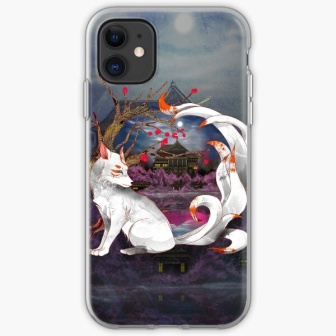Create a whimsical narrative involving all elements of this image. Once upon a time, in the heart of an enchanted realm, there lived a wise and mystical white fox named Luminara. Luminara resided in the ancient castle perched atop a mystical hill that shimmered in the moonlight. Every full moon, the castle would glow with an ethereal light, becoming a beacon of magic and mystery.

One moonlit night, Luminara received a golden ribbon from the Moon Goddess, which when worn, granted the ability to traverse between the realms of reality and dreams. Wrapped in this divine ribbon, Luminara set out on a journey across the night-cloaked landscape, her tail trailing like a comet across the sky.

Travelling through fields of vibrant red flowers and passing ancient, gnarled trees, Luminara encountered various fantastical creatures - from talking owls to dancing fireflies. Each interaction brought new wisdom and reflections on the balance of nature and magic.

Luminara’s quest was to uncover the secrets hidden by the luminescent moon and to bring harmony between the mythical and mortal worlds. With every step, her journey weaved a tapestry of dreams, illuminating the cosmic dance between the stars and the earth below. And thus, the legend of Luminara, the guardian fox of dreams, became an everlasting tale in the hearts of all enchanted by the night.  What historical or cultural elements could be influencing the design in this image? The design appears to draw inspiration from various cultural and historical elements. The fox, a prominent figure in many folklore traditions, especially in East Asian cultures, often symbolizes wisdom, protection, and mystical powers. The ribbon might reference ancient myths where such accessories possess magical properties or signify noble status.

The castle evokes imagery of medieval or feudal architecture, suggesting a setting rich in history and intrigue. The full moon and its influence are pervasive in cultures worldwide, often associated with transformation, purity, and emotional depth. The vivid red flowers could symbolize life force and vitality, common in many cultural representations of beauty and transience. The combination of these elements creates a design steeped in cultural significance and historical depth, offering layers of interpretation and meaning. 